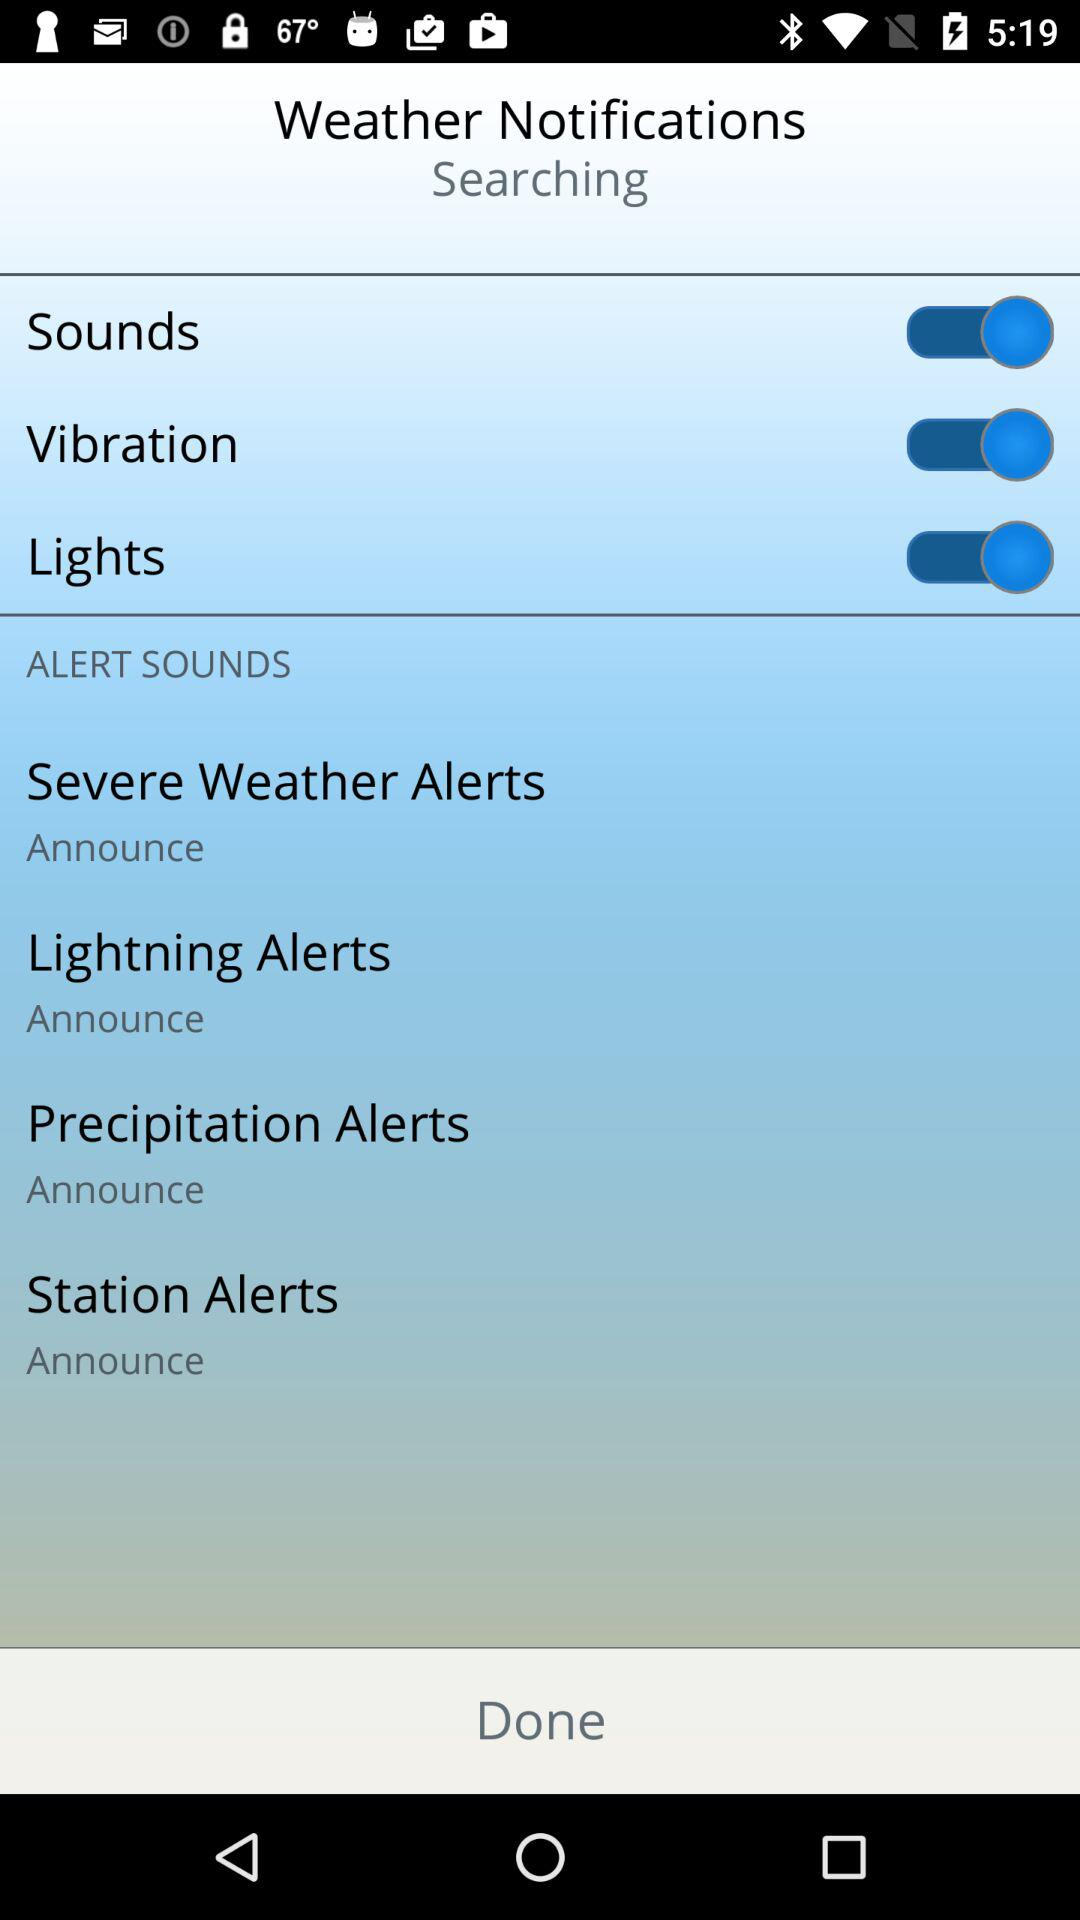How many alert sound options are there?
Answer the question using a single word or phrase. 4 